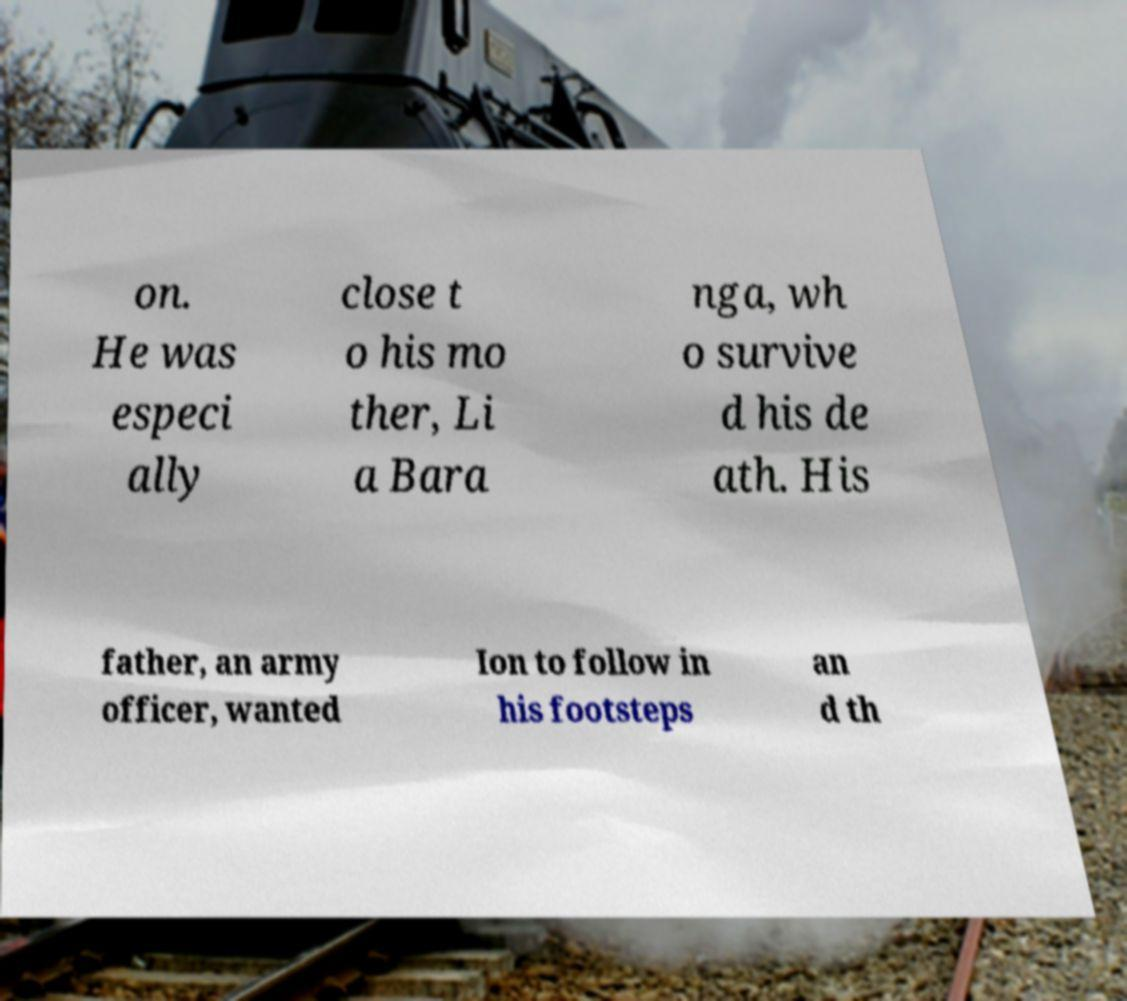Please identify and transcribe the text found in this image. on. He was especi ally close t o his mo ther, Li a Bara nga, wh o survive d his de ath. His father, an army officer, wanted Ion to follow in his footsteps an d th 